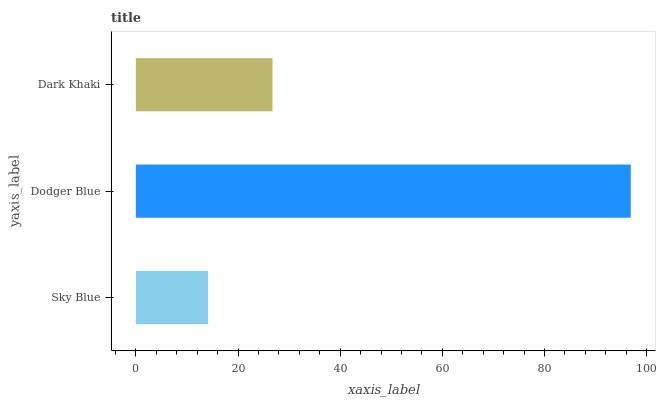Is Sky Blue the minimum?
Answer yes or no. Yes. Is Dodger Blue the maximum?
Answer yes or no. Yes. Is Dark Khaki the minimum?
Answer yes or no. No. Is Dark Khaki the maximum?
Answer yes or no. No. Is Dodger Blue greater than Dark Khaki?
Answer yes or no. Yes. Is Dark Khaki less than Dodger Blue?
Answer yes or no. Yes. Is Dark Khaki greater than Dodger Blue?
Answer yes or no. No. Is Dodger Blue less than Dark Khaki?
Answer yes or no. No. Is Dark Khaki the high median?
Answer yes or no. Yes. Is Dark Khaki the low median?
Answer yes or no. Yes. Is Sky Blue the high median?
Answer yes or no. No. Is Dodger Blue the low median?
Answer yes or no. No. 